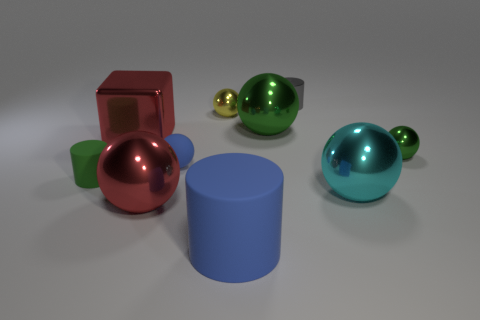The other matte thing that is the same size as the cyan object is what shape?
Ensure brevity in your answer.  Cylinder. Do the tiny gray object and the small green rubber thing have the same shape?
Offer a terse response. Yes. How many gray metallic objects are the same shape as the large green object?
Provide a succinct answer. 0. There is a large green shiny object; what number of big green balls are in front of it?
Your answer should be very brief. 0. There is a big sphere behind the cube; does it have the same color as the small metal cylinder?
Your answer should be compact. No. How many cubes have the same size as the blue rubber ball?
Ensure brevity in your answer.  0. There is a cyan object that is made of the same material as the red cube; what shape is it?
Keep it short and to the point. Sphere. Are there any small things of the same color as the shiny block?
Offer a terse response. No. What material is the big green thing?
Provide a short and direct response. Metal. How many objects are either big cubes or cyan balls?
Provide a short and direct response. 2. 